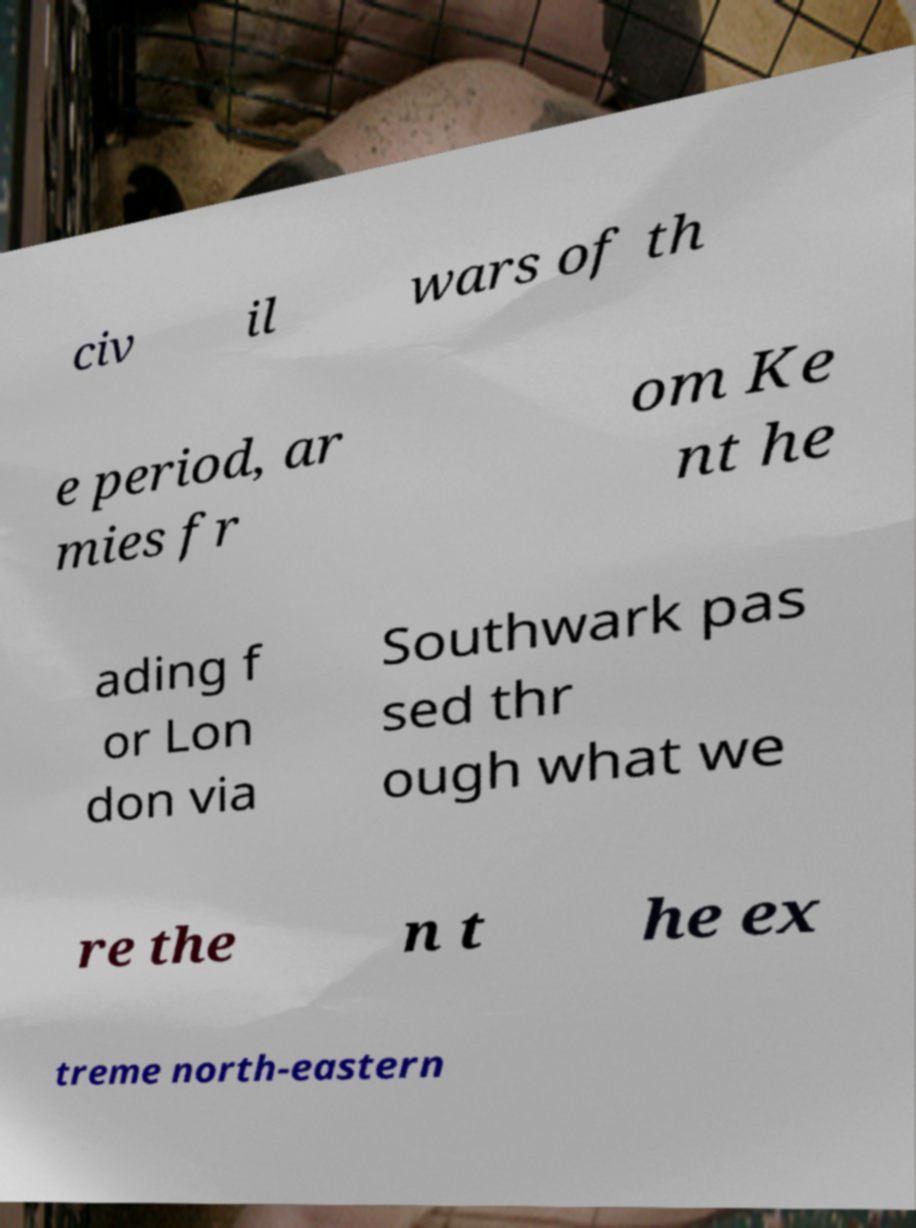Can you read and provide the text displayed in the image?This photo seems to have some interesting text. Can you extract and type it out for me? civ il wars of th e period, ar mies fr om Ke nt he ading f or Lon don via Southwark pas sed thr ough what we re the n t he ex treme north-eastern 